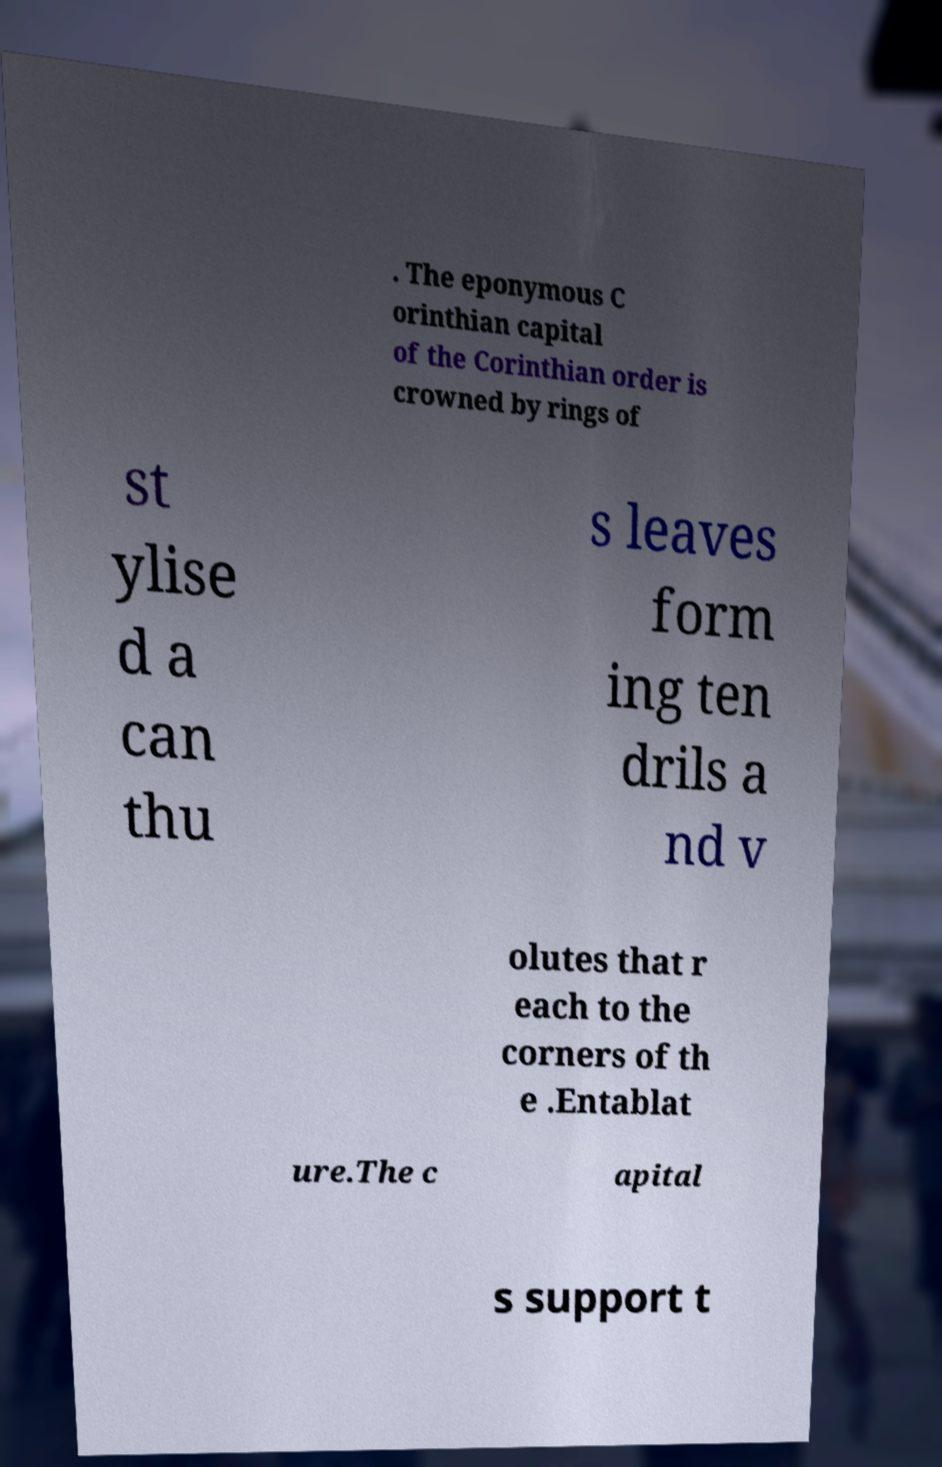Can you read and provide the text displayed in the image?This photo seems to have some interesting text. Can you extract and type it out for me? . The eponymous C orinthian capital of the Corinthian order is crowned by rings of st ylise d a can thu s leaves form ing ten drils a nd v olutes that r each to the corners of th e .Entablat ure.The c apital s support t 